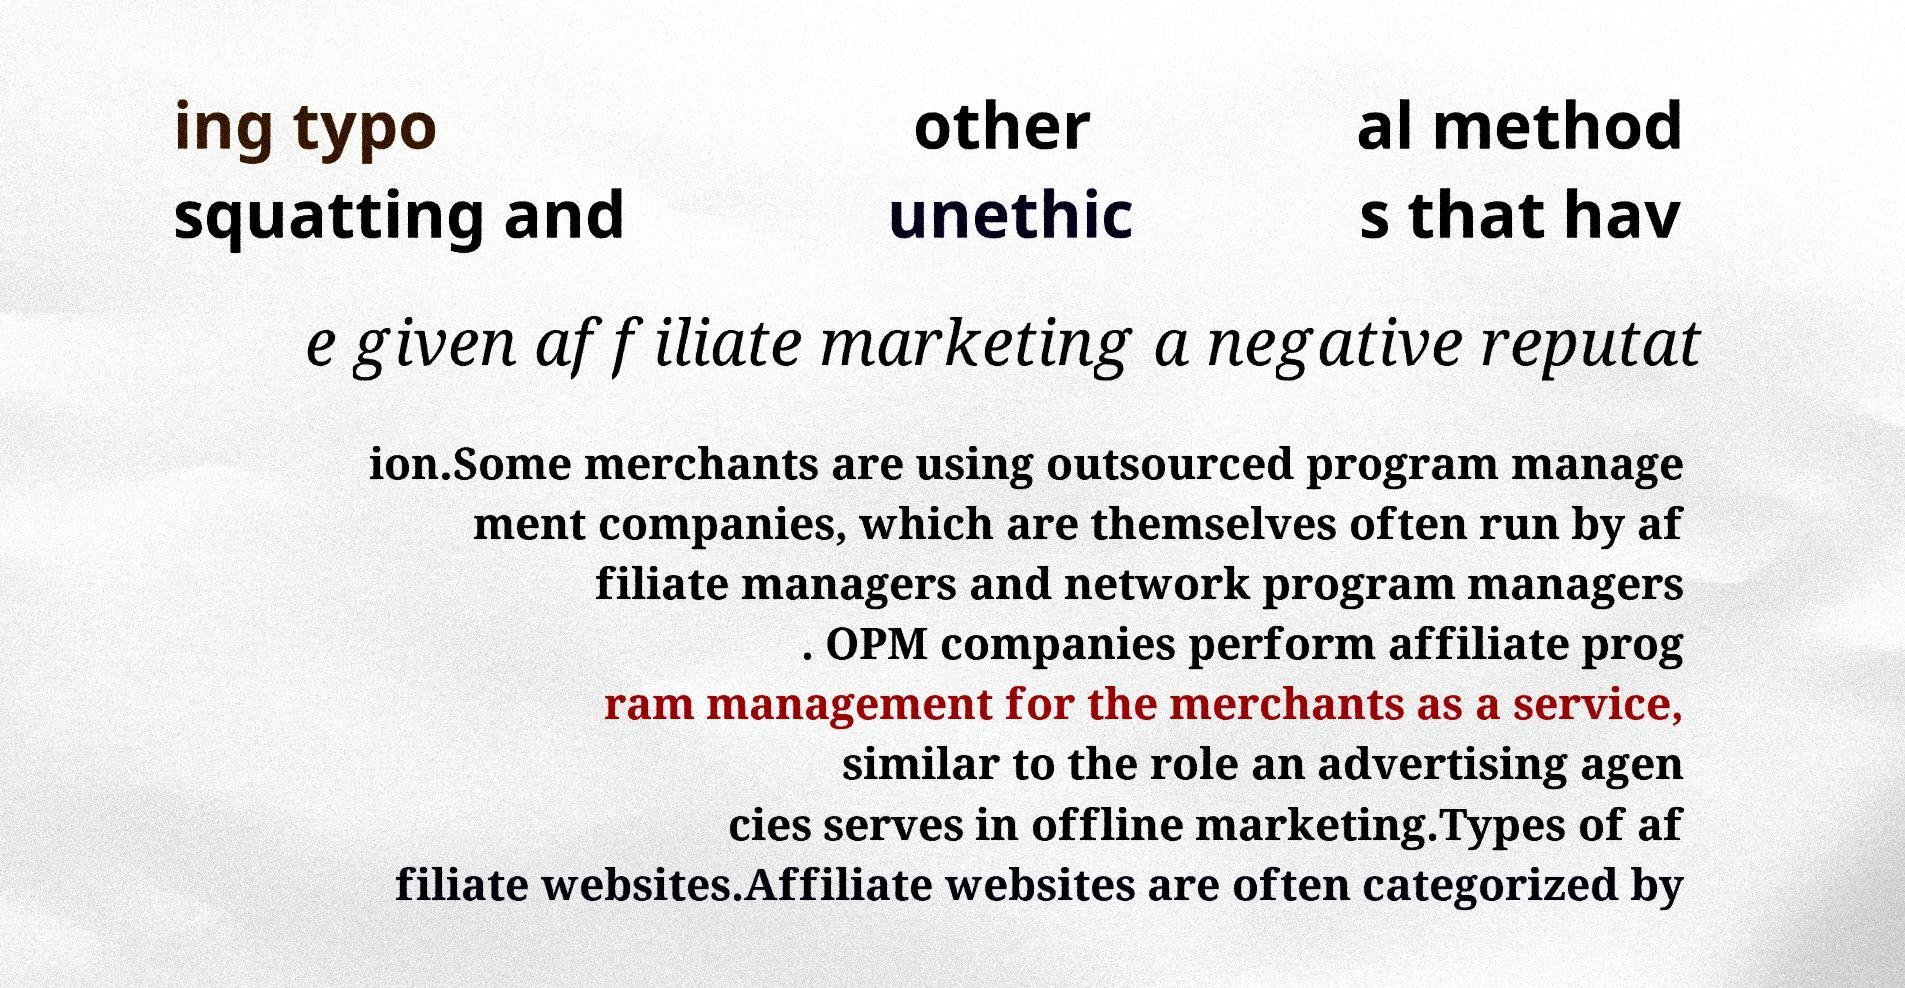There's text embedded in this image that I need extracted. Can you transcribe it verbatim? ing typo squatting and other unethic al method s that hav e given affiliate marketing a negative reputat ion.Some merchants are using outsourced program manage ment companies, which are themselves often run by af filiate managers and network program managers . OPM companies perform affiliate prog ram management for the merchants as a service, similar to the role an advertising agen cies serves in offline marketing.Types of af filiate websites.Affiliate websites are often categorized by 